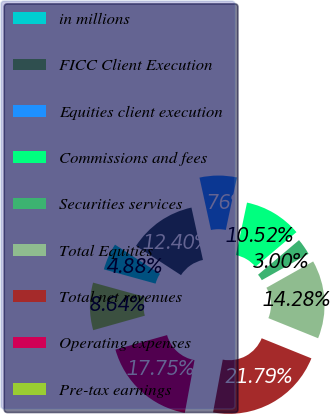Convert chart to OTSL. <chart><loc_0><loc_0><loc_500><loc_500><pie_chart><fcel>in millions<fcel>FICC Client Execution<fcel>Equities client execution<fcel>Commissions and fees<fcel>Securities services<fcel>Total Equities<fcel>Total net revenues<fcel>Operating expenses<fcel>Pre-tax earnings<nl><fcel>4.88%<fcel>12.4%<fcel>6.76%<fcel>10.52%<fcel>3.0%<fcel>14.28%<fcel>21.79%<fcel>17.75%<fcel>8.64%<nl></chart> 